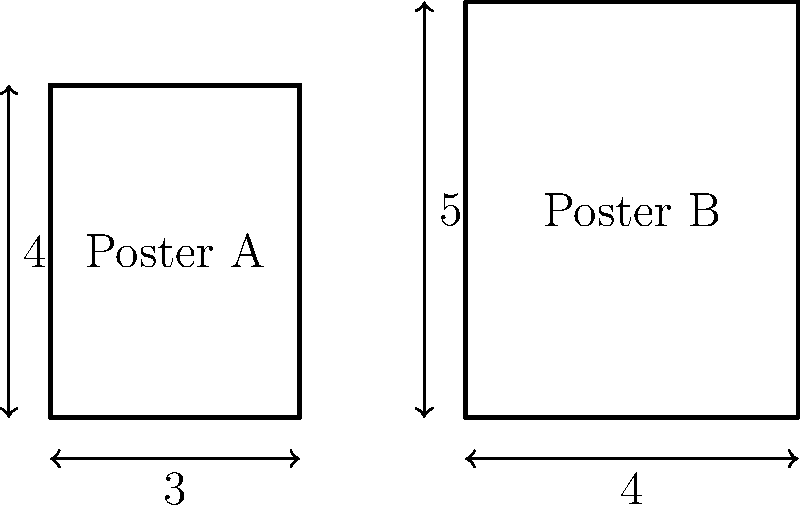Two vintage movie posters from the Golden Age of Hollywood are shown above. Poster A has dimensions 3x4, while Poster B has dimensions 4x5. If you were to scale up Poster A to have the same area as Poster B, what would be the new width of Poster A (rounded to two decimal places)? To solve this problem, let's follow these steps:

1. Calculate the area of Poster B:
   Area of Poster B = $4 \times 5 = 20$ square units

2. Set up an equation for the scaled Poster A to have the same area:
   Let $x$ be the scale factor.
   $(3x)(4x) = 20$

3. Solve the equation:
   $12x^2 = 20$
   $x^2 = \frac{20}{12} = \frac{5}{3}$
   $x = \sqrt{\frac{5}{3}} \approx 1.2909$

4. Calculate the new width of Poster A:
   New width = $3 \times 1.2909 \approx 3.8728$

5. Round to two decimal places:
   $3.87$

Therefore, if Poster A were scaled up to have the same area as Poster B, its new width would be 3.87 units.
Answer: 3.87 